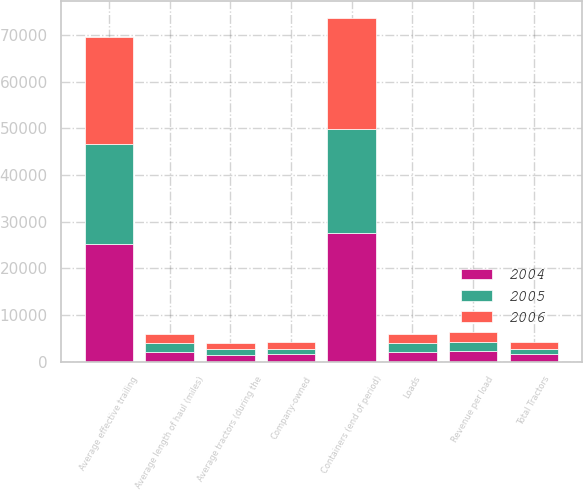Convert chart. <chart><loc_0><loc_0><loc_500><loc_500><stacked_bar_chart><ecel><fcel>Loads<fcel>Average length of haul (miles)<fcel>Revenue per load<fcel>Average tractors (during the<fcel>Company-owned<fcel>Total Tractors<fcel>Containers (end of period)<fcel>Average effective trailing<nl><fcel>2004<fcel>1982<fcel>1989<fcel>2272<fcel>1485<fcel>1551<fcel>1574<fcel>27622<fcel>25219<nl><fcel>2006<fcel>1982<fcel>2010<fcel>2145<fcel>1259<fcel>1341<fcel>1357<fcel>23755<fcel>22881<nl><fcel>2005<fcel>1982<fcel>1982<fcel>1917<fcel>1141<fcel>1192<fcel>1192<fcel>22210<fcel>21409<nl></chart> 